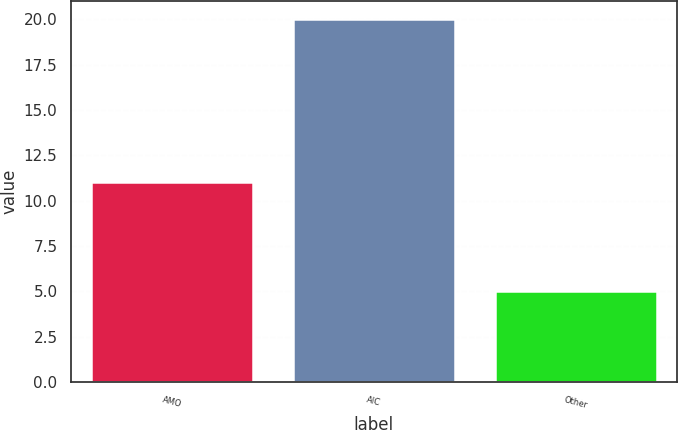<chart> <loc_0><loc_0><loc_500><loc_500><bar_chart><fcel>AMO<fcel>AIC<fcel>Other<nl><fcel>11<fcel>20<fcel>5<nl></chart> 